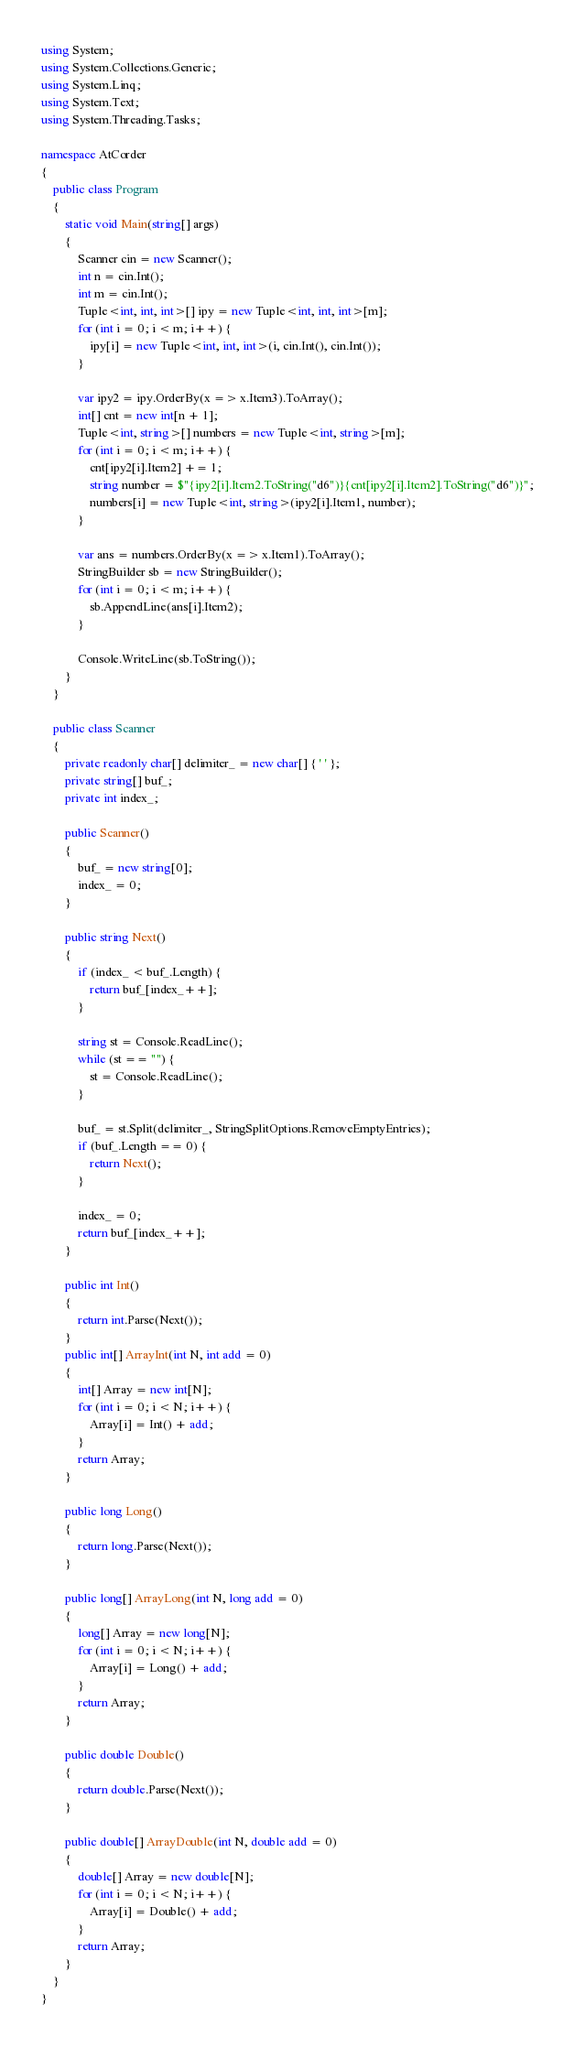Convert code to text. <code><loc_0><loc_0><loc_500><loc_500><_C#_>using System;
using System.Collections.Generic;
using System.Linq;
using System.Text;
using System.Threading.Tasks;

namespace AtCorder
{
	public class Program
	{
		static void Main(string[] args)
		{
			Scanner cin = new Scanner();
			int n = cin.Int();
			int m = cin.Int();
			Tuple<int, int, int>[] ipy = new Tuple<int, int, int>[m];
			for (int i = 0; i < m; i++) {
				ipy[i] = new Tuple<int, int, int>(i, cin.Int(), cin.Int());
			}

			var ipy2 = ipy.OrderBy(x => x.Item3).ToArray();
			int[] cnt = new int[n + 1];
			Tuple<int, string>[] numbers = new Tuple<int, string>[m];
			for (int i = 0; i < m; i++) {
				cnt[ipy2[i].Item2] += 1;
				string number = $"{ipy2[i].Item2.ToString("d6")}{cnt[ipy2[i].Item2].ToString("d6")}";
				numbers[i] = new Tuple<int, string>(ipy2[i].Item1, number);
			}

			var ans = numbers.OrderBy(x => x.Item1).ToArray();
			StringBuilder sb = new StringBuilder();
			for (int i = 0; i < m; i++) {
				sb.AppendLine(ans[i].Item2);
			}

			Console.WriteLine(sb.ToString());
		}	
	}

	public class Scanner
	{
		private readonly char[] delimiter_ = new char[] { ' ' };
		private string[] buf_;
		private int index_;
		
		public Scanner()
		{
			buf_ = new string[0];
			index_ = 0;
		}

		public string Next()
		{
			if (index_ < buf_.Length) {
				return buf_[index_++];
			}

			string st = Console.ReadLine();
			while (st == "") {
				st = Console.ReadLine();
			}

			buf_ = st.Split(delimiter_, StringSplitOptions.RemoveEmptyEntries);
			if (buf_.Length == 0) {
				return Next();
			}

			index_ = 0;
			return buf_[index_++];
		}

		public int Int()
		{
			return int.Parse(Next());
		}
		public int[] ArrayInt(int N, int add = 0)
		{
			int[] Array = new int[N];
			for (int i = 0; i < N; i++) {
				Array[i] = Int() + add;
			}
			return Array;
		}

		public long Long()
		{
			return long.Parse(Next());
		}

		public long[] ArrayLong(int N, long add = 0)
		{
			long[] Array = new long[N];
			for (int i = 0; i < N; i++) {
				Array[i] = Long() + add;
			}
			return Array;
		}

		public double Double()
		{
			return double.Parse(Next());
		}

		public double[] ArrayDouble(int N, double add = 0)
		{
			double[] Array = new double[N];
			for (int i = 0; i < N; i++) {
				Array[i] = Double() + add;
			}
			return Array;
		}
	}
}
</code> 